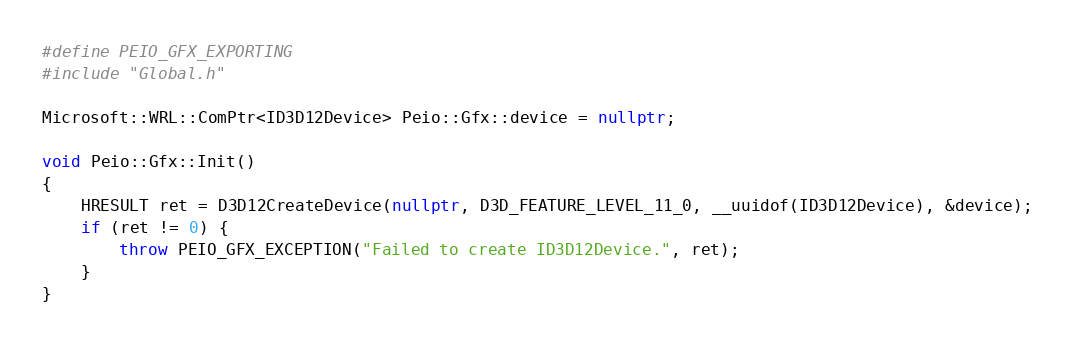<code> <loc_0><loc_0><loc_500><loc_500><_C++_>#define PEIO_GFX_EXPORTING
#include "Global.h"

Microsoft::WRL::ComPtr<ID3D12Device> Peio::Gfx::device = nullptr;

void Peio::Gfx::Init()
{
	HRESULT ret = D3D12CreateDevice(nullptr, D3D_FEATURE_LEVEL_11_0, __uuidof(ID3D12Device), &device);
	if (ret != 0) {
		throw PEIO_GFX_EXCEPTION("Failed to create ID3D12Device.", ret);
	}
}
</code> 